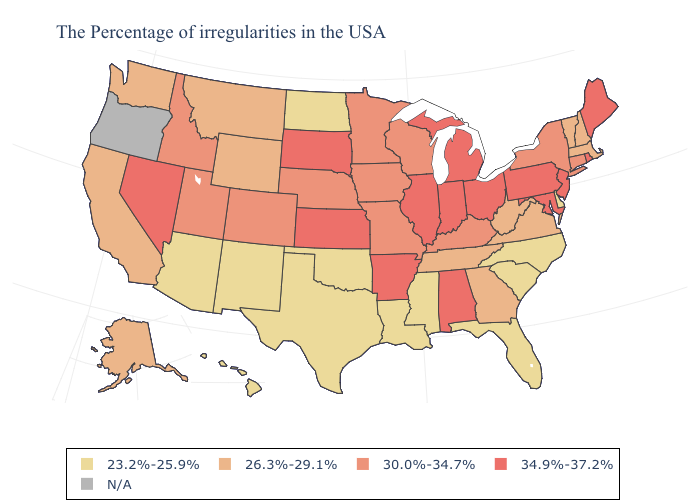What is the highest value in states that border Massachusetts?
Quick response, please. 34.9%-37.2%. Which states have the lowest value in the West?
Answer briefly. New Mexico, Arizona, Hawaii. Name the states that have a value in the range N/A?
Concise answer only. Oregon. Does Oklahoma have the lowest value in the USA?
Be succinct. Yes. What is the highest value in states that border Michigan?
Answer briefly. 34.9%-37.2%. Which states have the lowest value in the MidWest?
Answer briefly. North Dakota. What is the value of New Hampshire?
Give a very brief answer. 26.3%-29.1%. Name the states that have a value in the range 34.9%-37.2%?
Quick response, please. Maine, Rhode Island, New Jersey, Maryland, Pennsylvania, Ohio, Michigan, Indiana, Alabama, Illinois, Arkansas, Kansas, South Dakota, Nevada. What is the highest value in the West ?
Write a very short answer. 34.9%-37.2%. Which states hav the highest value in the Northeast?
Quick response, please. Maine, Rhode Island, New Jersey, Pennsylvania. Which states hav the highest value in the South?
Write a very short answer. Maryland, Alabama, Arkansas. What is the value of Colorado?
Be succinct. 30.0%-34.7%. Name the states that have a value in the range 34.9%-37.2%?
Give a very brief answer. Maine, Rhode Island, New Jersey, Maryland, Pennsylvania, Ohio, Michigan, Indiana, Alabama, Illinois, Arkansas, Kansas, South Dakota, Nevada. Does West Virginia have the lowest value in the USA?
Keep it brief. No. Does New Hampshire have the lowest value in the Northeast?
Answer briefly. Yes. 